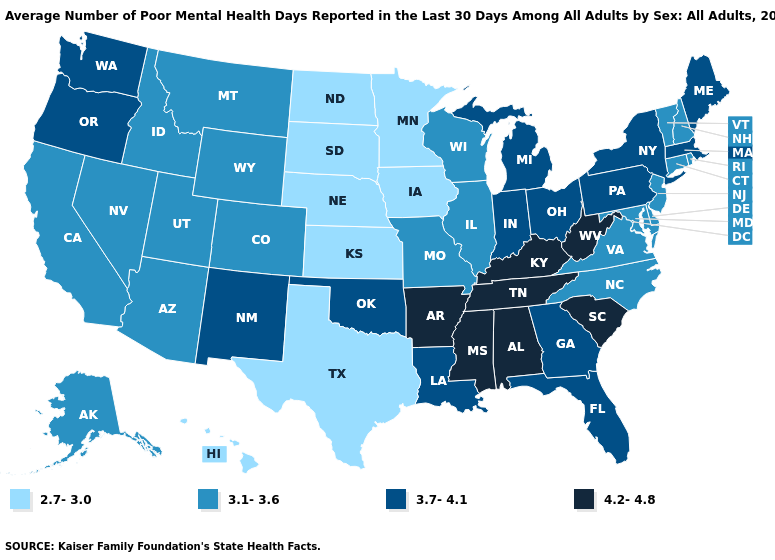What is the value of Illinois?
Answer briefly. 3.1-3.6. Does the map have missing data?
Write a very short answer. No. Name the states that have a value in the range 2.7-3.0?
Quick response, please. Hawaii, Iowa, Kansas, Minnesota, Nebraska, North Dakota, South Dakota, Texas. What is the highest value in states that border Maryland?
Write a very short answer. 4.2-4.8. Name the states that have a value in the range 3.7-4.1?
Write a very short answer. Florida, Georgia, Indiana, Louisiana, Maine, Massachusetts, Michigan, New Mexico, New York, Ohio, Oklahoma, Oregon, Pennsylvania, Washington. Name the states that have a value in the range 3.1-3.6?
Concise answer only. Alaska, Arizona, California, Colorado, Connecticut, Delaware, Idaho, Illinois, Maryland, Missouri, Montana, Nevada, New Hampshire, New Jersey, North Carolina, Rhode Island, Utah, Vermont, Virginia, Wisconsin, Wyoming. Name the states that have a value in the range 4.2-4.8?
Short answer required. Alabama, Arkansas, Kentucky, Mississippi, South Carolina, Tennessee, West Virginia. What is the value of Kansas?
Concise answer only. 2.7-3.0. What is the value of Montana?
Keep it brief. 3.1-3.6. What is the value of West Virginia?
Keep it brief. 4.2-4.8. Name the states that have a value in the range 3.1-3.6?
Answer briefly. Alaska, Arizona, California, Colorado, Connecticut, Delaware, Idaho, Illinois, Maryland, Missouri, Montana, Nevada, New Hampshire, New Jersey, North Carolina, Rhode Island, Utah, Vermont, Virginia, Wisconsin, Wyoming. Name the states that have a value in the range 4.2-4.8?
Quick response, please. Alabama, Arkansas, Kentucky, Mississippi, South Carolina, Tennessee, West Virginia. Name the states that have a value in the range 2.7-3.0?
Be succinct. Hawaii, Iowa, Kansas, Minnesota, Nebraska, North Dakota, South Dakota, Texas. What is the highest value in states that border Kansas?
Write a very short answer. 3.7-4.1. What is the value of Texas?
Write a very short answer. 2.7-3.0. 